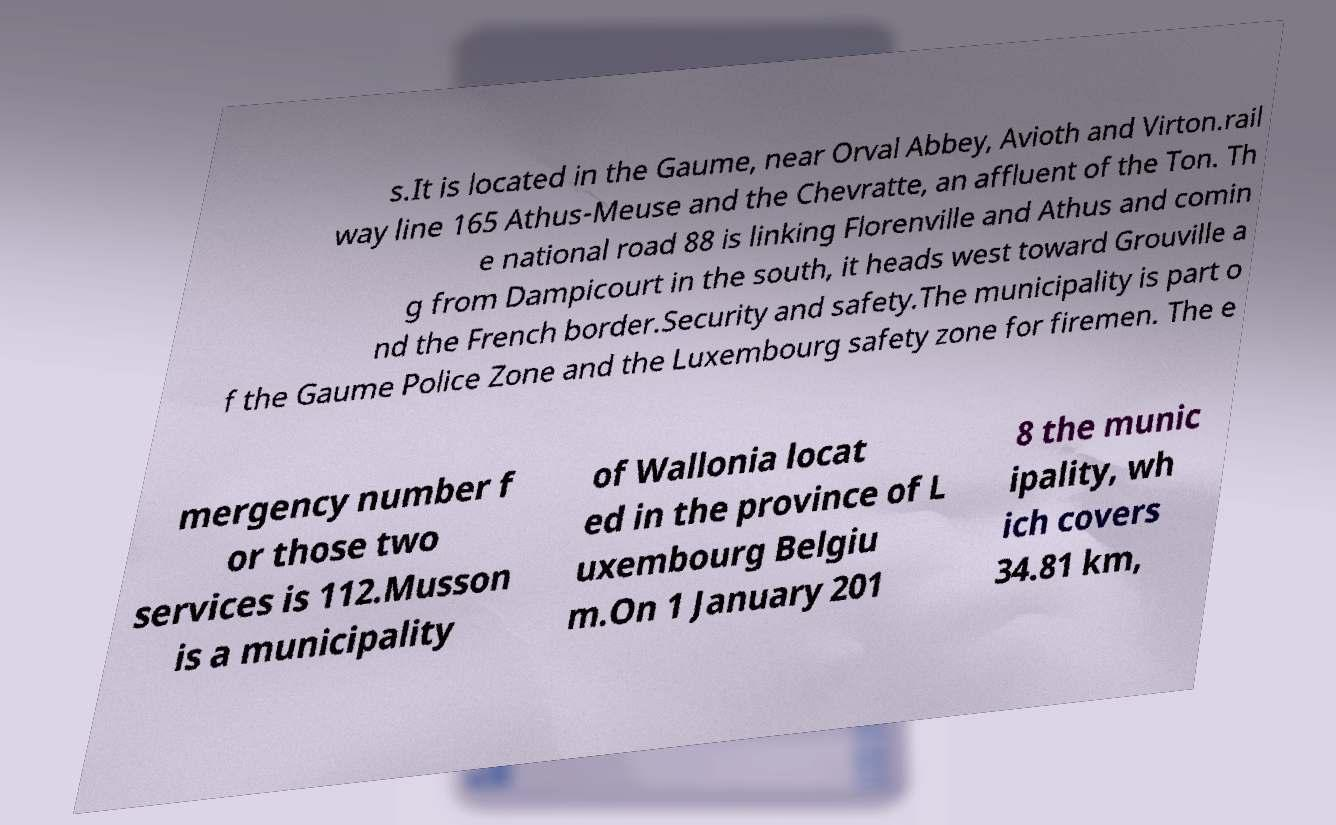What messages or text are displayed in this image? I need them in a readable, typed format. s.It is located in the Gaume, near Orval Abbey, Avioth and Virton.rail way line 165 Athus-Meuse and the Chevratte, an affluent of the Ton. Th e national road 88 is linking Florenville and Athus and comin g from Dampicourt in the south, it heads west toward Grouville a nd the French border.Security and safety.The municipality is part o f the Gaume Police Zone and the Luxembourg safety zone for firemen. The e mergency number f or those two services is 112.Musson is a municipality of Wallonia locat ed in the province of L uxembourg Belgiu m.On 1 January 201 8 the munic ipality, wh ich covers 34.81 km, 